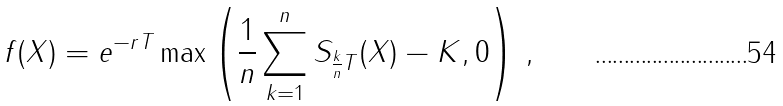Convert formula to latex. <formula><loc_0><loc_0><loc_500><loc_500>f ( X ) = e ^ { - r T } \max \left ( \frac { 1 } { n } \sum _ { k = 1 } ^ { n } S _ { \frac { k } { n } T } ( X ) - K , 0 \right ) \, ,</formula> 